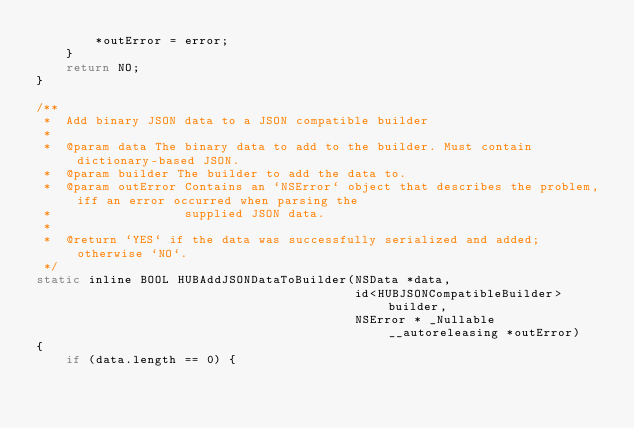Convert code to text. <code><loc_0><loc_0><loc_500><loc_500><_C_>        *outError = error;
    }
    return NO;
}

/**
 *  Add binary JSON data to a JSON compatible builder
 *
 *  @param data The binary data to add to the builder. Must contain dictionary-based JSON.
 *  @param builder The builder to add the data to.
 *  @param outError Contains an `NSError` object that describes the problem, iff an error occurred when parsing the
 *                  supplied JSON data.
 *
 *  @return `YES` if the data was successfully serialized and added; otherwise `NO`.
 */
static inline BOOL HUBAddJSONDataToBuilder(NSData *data,
                                           id<HUBJSONCompatibleBuilder> builder,
                                           NSError * _Nullable __autoreleasing *outError)
{
    if (data.length == 0) {</code> 